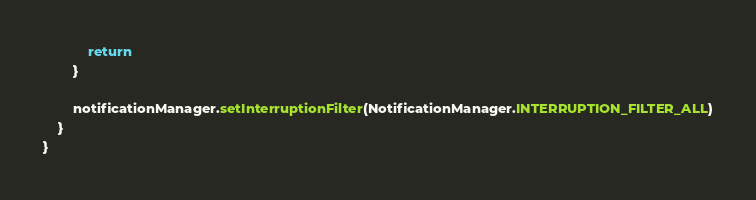<code> <loc_0><loc_0><loc_500><loc_500><_Kotlin_>            return
        }

        notificationManager.setInterruptionFilter(NotificationManager.INTERRUPTION_FILTER_ALL)
    }
}</code> 